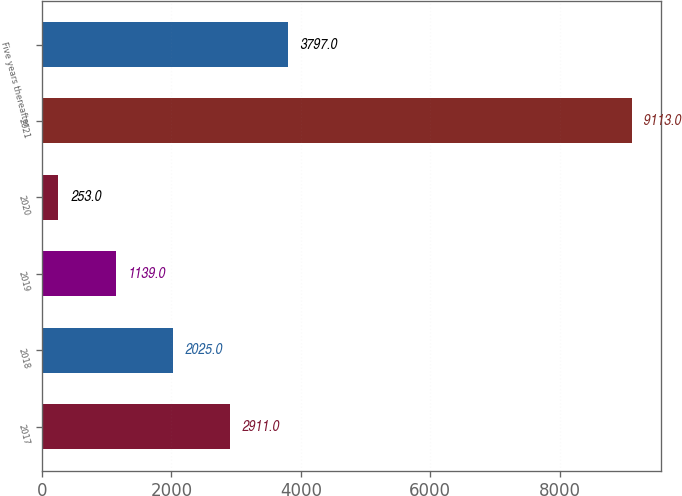Convert chart to OTSL. <chart><loc_0><loc_0><loc_500><loc_500><bar_chart><fcel>2017<fcel>2018<fcel>2019<fcel>2020<fcel>2021<fcel>Five years thereafter<nl><fcel>2911<fcel>2025<fcel>1139<fcel>253<fcel>9113<fcel>3797<nl></chart> 